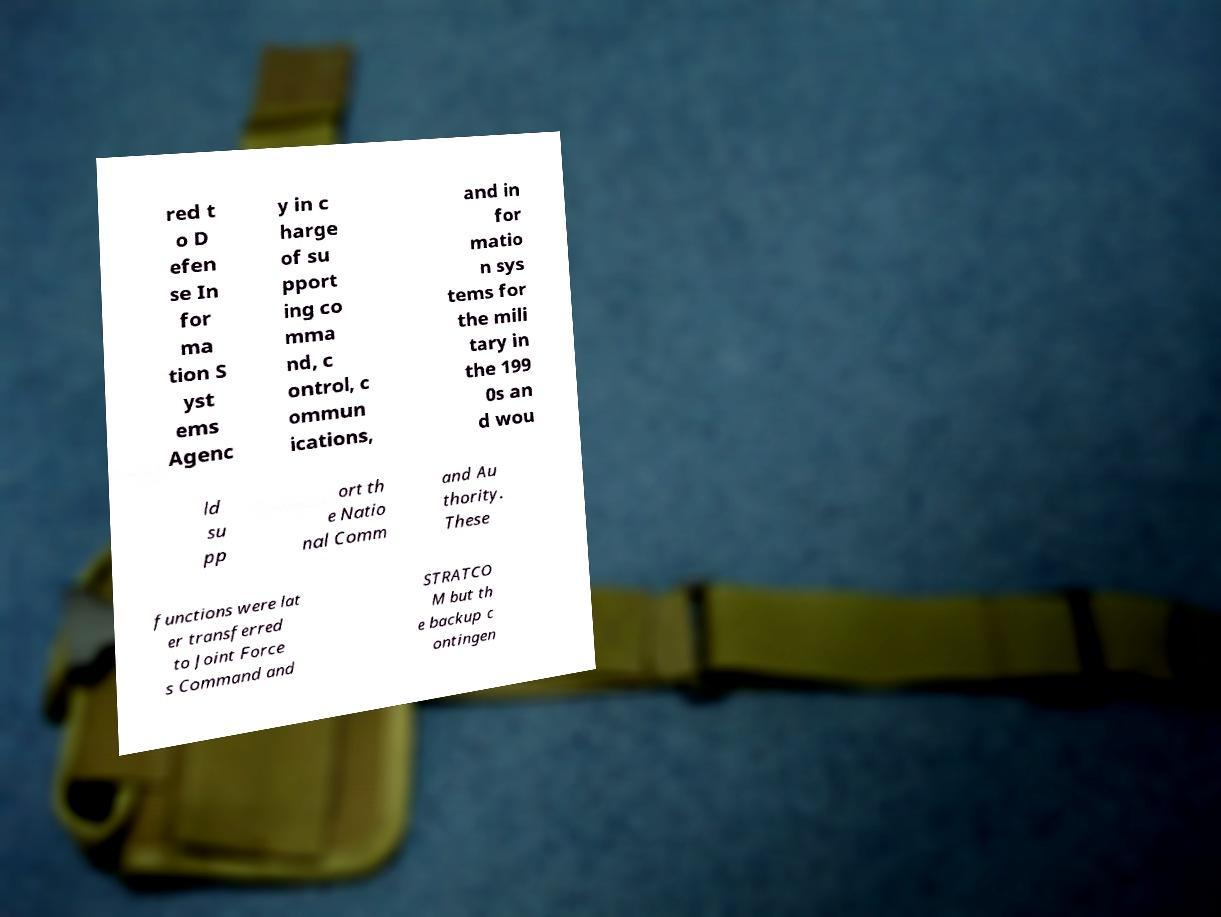I need the written content from this picture converted into text. Can you do that? red t o D efen se In for ma tion S yst ems Agenc y in c harge of su pport ing co mma nd, c ontrol, c ommun ications, and in for matio n sys tems for the mili tary in the 199 0s an d wou ld su pp ort th e Natio nal Comm and Au thority. These functions were lat er transferred to Joint Force s Command and STRATCO M but th e backup c ontingen 